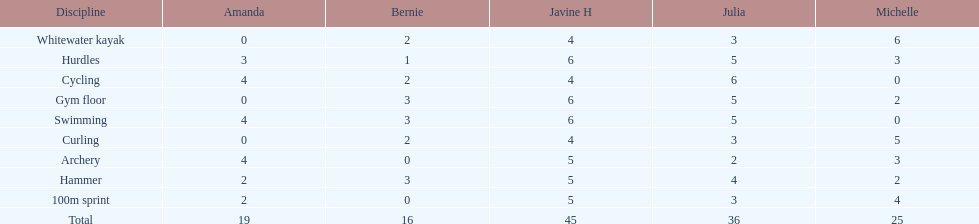What is the first discipline listed on this chart? Whitewater kayak. 